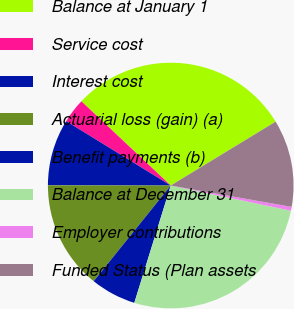<chart> <loc_0><loc_0><loc_500><loc_500><pie_chart><fcel>Balance at January 1<fcel>Service cost<fcel>Interest cost<fcel>Actuarial loss (gain) (a)<fcel>Benefit payments (b)<fcel>Balance at December 31<fcel>Employer contributions<fcel>Funded Status (Plan assets<nl><fcel>29.26%<fcel>3.25%<fcel>8.75%<fcel>14.24%<fcel>6.0%<fcel>26.51%<fcel>0.5%<fcel>11.49%<nl></chart> 